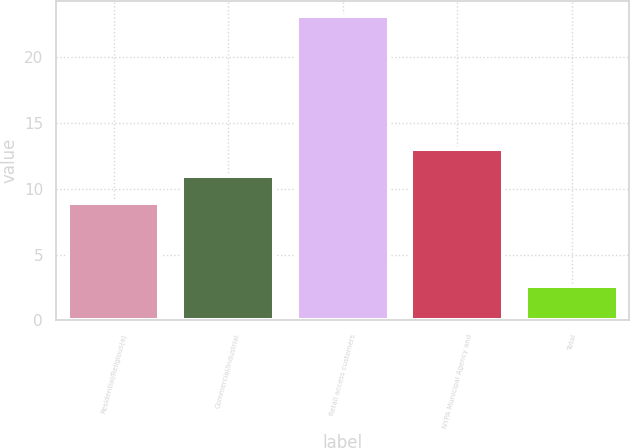Convert chart. <chart><loc_0><loc_0><loc_500><loc_500><bar_chart><fcel>Residential/Religious(a)<fcel>Commercial/Industrial<fcel>Retail access customers<fcel>NYPA Municipal Agency and<fcel>Total<nl><fcel>8.9<fcel>10.95<fcel>23.1<fcel>13<fcel>2.6<nl></chart> 